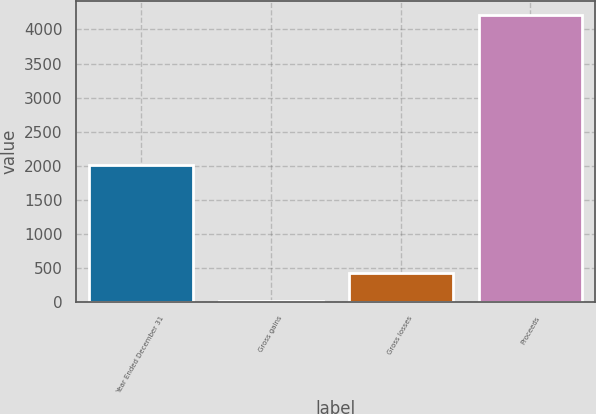Convert chart. <chart><loc_0><loc_0><loc_500><loc_500><bar_chart><fcel>Year Ended December 31<fcel>Gross gains<fcel>Gross losses<fcel>Proceeds<nl><fcel>2013<fcel>12<fcel>432<fcel>4212<nl></chart> 